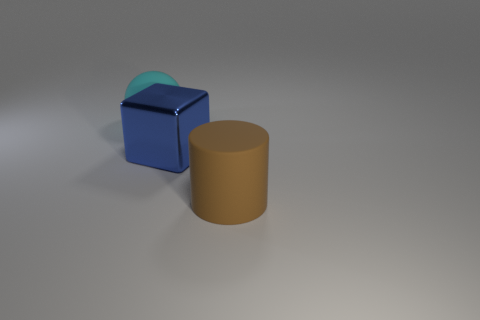There is a matte object that is behind the matte cylinder; how big is it? The matte object behind the cylinder appears to be a cube with a semitransparent sphere resting on top of it. While its exact dimensions cannot be determined from this angle, the cube appears to be roughly the same height as the cylinder, which suggests it could be of comparable size to the cylinder's height. 